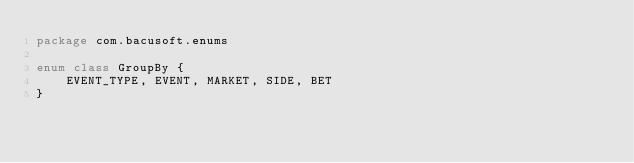Convert code to text. <code><loc_0><loc_0><loc_500><loc_500><_Kotlin_>package com.bacusoft.enums

enum class GroupBy {
    EVENT_TYPE, EVENT, MARKET, SIDE, BET
}</code> 